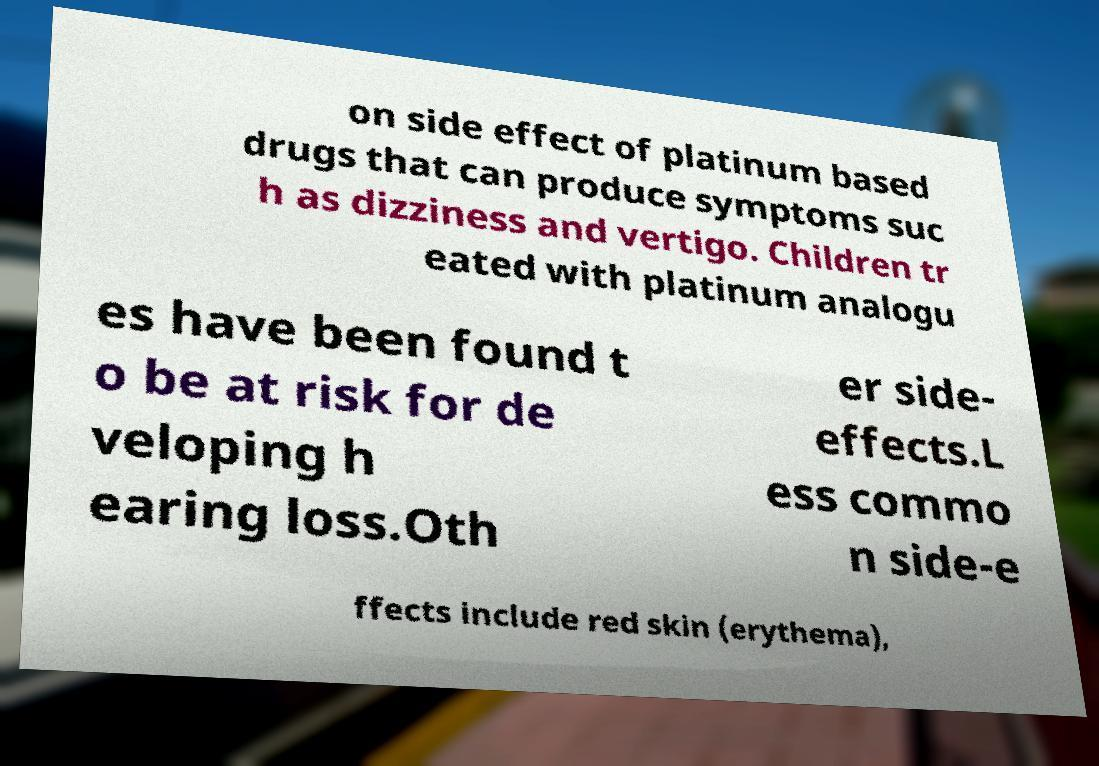Could you assist in decoding the text presented in this image and type it out clearly? on side effect of platinum based drugs that can produce symptoms suc h as dizziness and vertigo. Children tr eated with platinum analogu es have been found t o be at risk for de veloping h earing loss.Oth er side- effects.L ess commo n side-e ffects include red skin (erythema), 